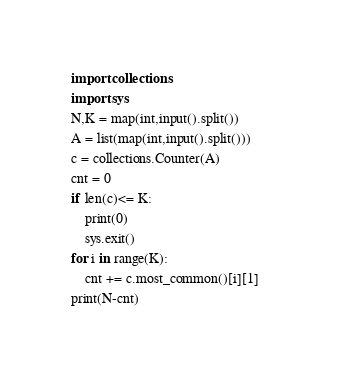Convert code to text. <code><loc_0><loc_0><loc_500><loc_500><_Python_>import collections
import sys
N,K = map(int,input().split())
A = list(map(int,input().split()))
c = collections.Counter(A)
cnt = 0
if len(c)<= K:
    print(0)
    sys.exit()
for i in range(K):
    cnt += c.most_common()[i][1]    
print(N-cnt)</code> 